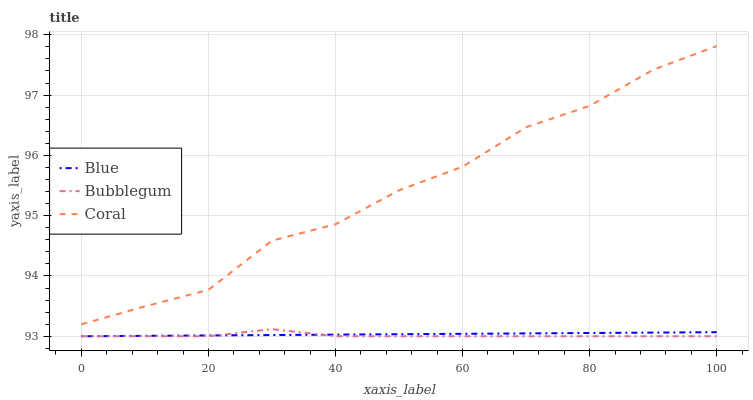Does Bubblegum have the minimum area under the curve?
Answer yes or no. Yes. Does Coral have the maximum area under the curve?
Answer yes or no. Yes. Does Coral have the minimum area under the curve?
Answer yes or no. No. Does Bubblegum have the maximum area under the curve?
Answer yes or no. No. Is Blue the smoothest?
Answer yes or no. Yes. Is Coral the roughest?
Answer yes or no. Yes. Is Bubblegum the smoothest?
Answer yes or no. No. Is Bubblegum the roughest?
Answer yes or no. No. Does Blue have the lowest value?
Answer yes or no. Yes. Does Coral have the lowest value?
Answer yes or no. No. Does Coral have the highest value?
Answer yes or no. Yes. Does Bubblegum have the highest value?
Answer yes or no. No. Is Blue less than Coral?
Answer yes or no. Yes. Is Coral greater than Blue?
Answer yes or no. Yes. Does Bubblegum intersect Blue?
Answer yes or no. Yes. Is Bubblegum less than Blue?
Answer yes or no. No. Is Bubblegum greater than Blue?
Answer yes or no. No. Does Blue intersect Coral?
Answer yes or no. No. 